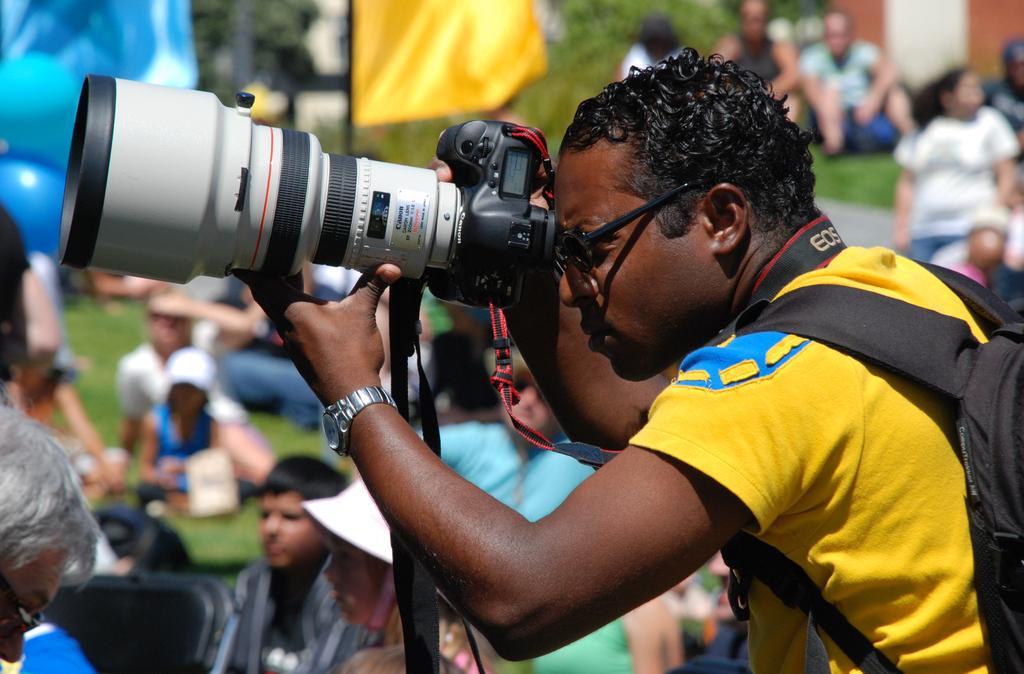In one or two sentences, can you explain what this image depicts? There is a man standing and holding camera behind him there are lot of people sitting beside a flag. 